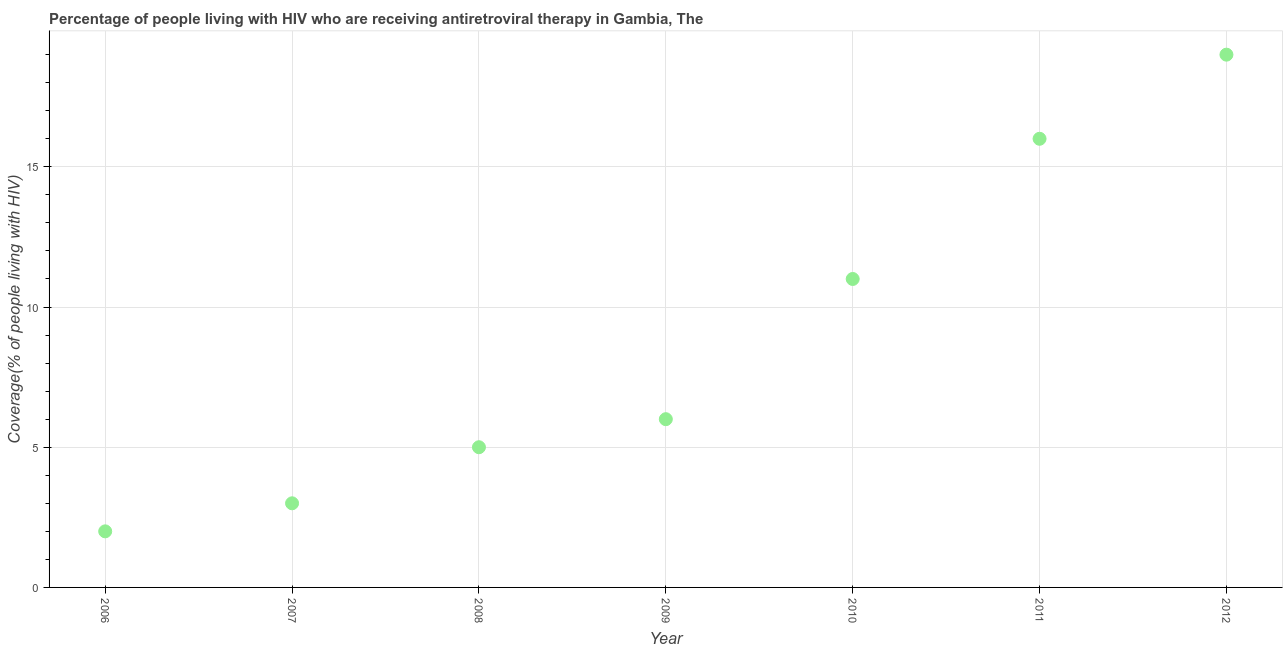What is the antiretroviral therapy coverage in 2007?
Offer a terse response. 3. Across all years, what is the maximum antiretroviral therapy coverage?
Give a very brief answer. 19. Across all years, what is the minimum antiretroviral therapy coverage?
Your response must be concise. 2. In which year was the antiretroviral therapy coverage maximum?
Offer a terse response. 2012. In which year was the antiretroviral therapy coverage minimum?
Your answer should be very brief. 2006. What is the sum of the antiretroviral therapy coverage?
Offer a terse response. 62. What is the difference between the antiretroviral therapy coverage in 2006 and 2011?
Your answer should be very brief. -14. What is the average antiretroviral therapy coverage per year?
Offer a very short reply. 8.86. In how many years, is the antiretroviral therapy coverage greater than 2 %?
Your answer should be very brief. 6. Do a majority of the years between 2009 and 2012 (inclusive) have antiretroviral therapy coverage greater than 10 %?
Provide a short and direct response. Yes. What is the ratio of the antiretroviral therapy coverage in 2008 to that in 2010?
Your response must be concise. 0.45. Is the antiretroviral therapy coverage in 2007 less than that in 2011?
Give a very brief answer. Yes. What is the difference between the highest and the second highest antiretroviral therapy coverage?
Offer a terse response. 3. Is the sum of the antiretroviral therapy coverage in 2011 and 2012 greater than the maximum antiretroviral therapy coverage across all years?
Offer a very short reply. Yes. What is the difference between the highest and the lowest antiretroviral therapy coverage?
Keep it short and to the point. 17. In how many years, is the antiretroviral therapy coverage greater than the average antiretroviral therapy coverage taken over all years?
Offer a very short reply. 3. Does the antiretroviral therapy coverage monotonically increase over the years?
Provide a short and direct response. Yes. How many years are there in the graph?
Give a very brief answer. 7. Are the values on the major ticks of Y-axis written in scientific E-notation?
Ensure brevity in your answer.  No. Does the graph contain any zero values?
Ensure brevity in your answer.  No. What is the title of the graph?
Ensure brevity in your answer.  Percentage of people living with HIV who are receiving antiretroviral therapy in Gambia, The. What is the label or title of the X-axis?
Make the answer very short. Year. What is the label or title of the Y-axis?
Provide a short and direct response. Coverage(% of people living with HIV). What is the Coverage(% of people living with HIV) in 2006?
Give a very brief answer. 2. What is the Coverage(% of people living with HIV) in 2007?
Your answer should be compact. 3. What is the Coverage(% of people living with HIV) in 2009?
Your answer should be very brief. 6. What is the Coverage(% of people living with HIV) in 2010?
Ensure brevity in your answer.  11. What is the Coverage(% of people living with HIV) in 2011?
Provide a succinct answer. 16. What is the difference between the Coverage(% of people living with HIV) in 2006 and 2007?
Ensure brevity in your answer.  -1. What is the difference between the Coverage(% of people living with HIV) in 2006 and 2008?
Offer a terse response. -3. What is the difference between the Coverage(% of people living with HIV) in 2006 and 2012?
Give a very brief answer. -17. What is the difference between the Coverage(% of people living with HIV) in 2007 and 2008?
Keep it short and to the point. -2. What is the difference between the Coverage(% of people living with HIV) in 2007 and 2009?
Keep it short and to the point. -3. What is the difference between the Coverage(% of people living with HIV) in 2007 and 2010?
Offer a very short reply. -8. What is the difference between the Coverage(% of people living with HIV) in 2008 and 2009?
Give a very brief answer. -1. What is the difference between the Coverage(% of people living with HIV) in 2008 and 2011?
Provide a succinct answer. -11. What is the difference between the Coverage(% of people living with HIV) in 2009 and 2010?
Offer a very short reply. -5. What is the difference between the Coverage(% of people living with HIV) in 2009 and 2011?
Your answer should be compact. -10. What is the difference between the Coverage(% of people living with HIV) in 2009 and 2012?
Your response must be concise. -13. What is the difference between the Coverage(% of people living with HIV) in 2010 and 2011?
Provide a short and direct response. -5. What is the ratio of the Coverage(% of people living with HIV) in 2006 to that in 2007?
Keep it short and to the point. 0.67. What is the ratio of the Coverage(% of people living with HIV) in 2006 to that in 2009?
Your response must be concise. 0.33. What is the ratio of the Coverage(% of people living with HIV) in 2006 to that in 2010?
Your response must be concise. 0.18. What is the ratio of the Coverage(% of people living with HIV) in 2006 to that in 2011?
Your answer should be compact. 0.12. What is the ratio of the Coverage(% of people living with HIV) in 2006 to that in 2012?
Provide a succinct answer. 0.1. What is the ratio of the Coverage(% of people living with HIV) in 2007 to that in 2008?
Your response must be concise. 0.6. What is the ratio of the Coverage(% of people living with HIV) in 2007 to that in 2010?
Give a very brief answer. 0.27. What is the ratio of the Coverage(% of people living with HIV) in 2007 to that in 2011?
Your answer should be very brief. 0.19. What is the ratio of the Coverage(% of people living with HIV) in 2007 to that in 2012?
Give a very brief answer. 0.16. What is the ratio of the Coverage(% of people living with HIV) in 2008 to that in 2009?
Your response must be concise. 0.83. What is the ratio of the Coverage(% of people living with HIV) in 2008 to that in 2010?
Provide a succinct answer. 0.46. What is the ratio of the Coverage(% of people living with HIV) in 2008 to that in 2011?
Make the answer very short. 0.31. What is the ratio of the Coverage(% of people living with HIV) in 2008 to that in 2012?
Provide a short and direct response. 0.26. What is the ratio of the Coverage(% of people living with HIV) in 2009 to that in 2010?
Ensure brevity in your answer.  0.55. What is the ratio of the Coverage(% of people living with HIV) in 2009 to that in 2012?
Your answer should be very brief. 0.32. What is the ratio of the Coverage(% of people living with HIV) in 2010 to that in 2011?
Your answer should be compact. 0.69. What is the ratio of the Coverage(% of people living with HIV) in 2010 to that in 2012?
Offer a terse response. 0.58. What is the ratio of the Coverage(% of people living with HIV) in 2011 to that in 2012?
Your response must be concise. 0.84. 